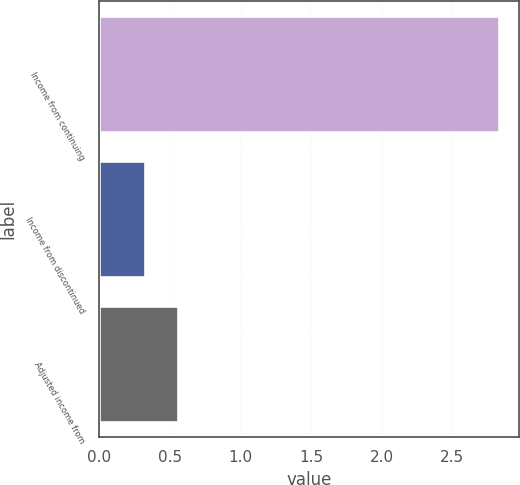Convert chart to OTSL. <chart><loc_0><loc_0><loc_500><loc_500><bar_chart><fcel>Income from continuing<fcel>Income from discontinued<fcel>Adjusted income from<nl><fcel>2.83<fcel>0.32<fcel>0.56<nl></chart> 